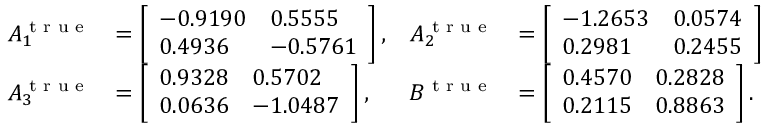Convert formula to latex. <formula><loc_0><loc_0><loc_500><loc_500>\begin{array} { r l r l } { A _ { 1 } ^ { t r u e } } & { = \left [ \begin{array} { l l } { - 0 . 9 1 9 0 } & { 0 . 5 5 5 5 } \\ { 0 . 4 9 3 6 } & { - 0 . 5 7 6 1 } \end{array} \right ] , } & { A _ { 2 } ^ { t r u e } } & { = \left [ \begin{array} { l l } { - 1 . 2 6 5 3 } & { 0 . 0 5 7 4 } \\ { 0 . 2 9 8 1 } & { 0 . 2 4 5 5 } \end{array} \right ] } \\ { A _ { 3 } ^ { t r u e } } & { = \left [ \begin{array} { l l } { 0 . 9 3 2 8 } & { 0 . 5 7 0 2 } \\ { 0 . 0 6 3 6 } & { - 1 . 0 4 8 7 } \end{array} \right ] , } & { B ^ { t r u e } } & { = \left [ \begin{array} { l l } { 0 . 4 5 7 0 } & { 0 . 2 8 2 8 } \\ { 0 . 2 1 1 5 } & { 0 . 8 8 6 3 } \end{array} \right ] . } \end{array}</formula> 